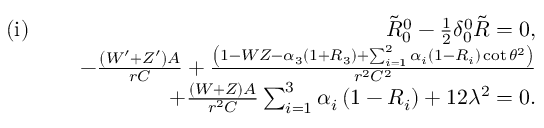Convert formula to latex. <formula><loc_0><loc_0><loc_500><loc_500>\begin{array} { r l r } { ( i ) \, } & { \tilde { R } _ { 0 } ^ { 0 } - \frac { 1 } { 2 } \delta _ { 0 } ^ { 0 } \tilde { R } = 0 , } \\ & { - \frac { \left ( W ^ { \prime } + Z ^ { \prime } \right ) A } { r C } + \frac { \left ( 1 - W Z - \alpha _ { 3 } \left ( 1 + R _ { 3 } \right ) + \sum _ { i = 1 } ^ { 2 } \alpha _ { i } \left ( 1 - R _ { i } \right ) \cot \theta ^ { 2 } \right ) } { r ^ { 2 } C ^ { 2 } } } \\ & { + \frac { ( W + Z ) A } { r ^ { 2 } C } \sum _ { i = 1 } ^ { 3 } \alpha _ { i } \left ( 1 - R _ { i } \right ) + 1 2 \lambda ^ { 2 } = 0 . } \end{array}</formula> 